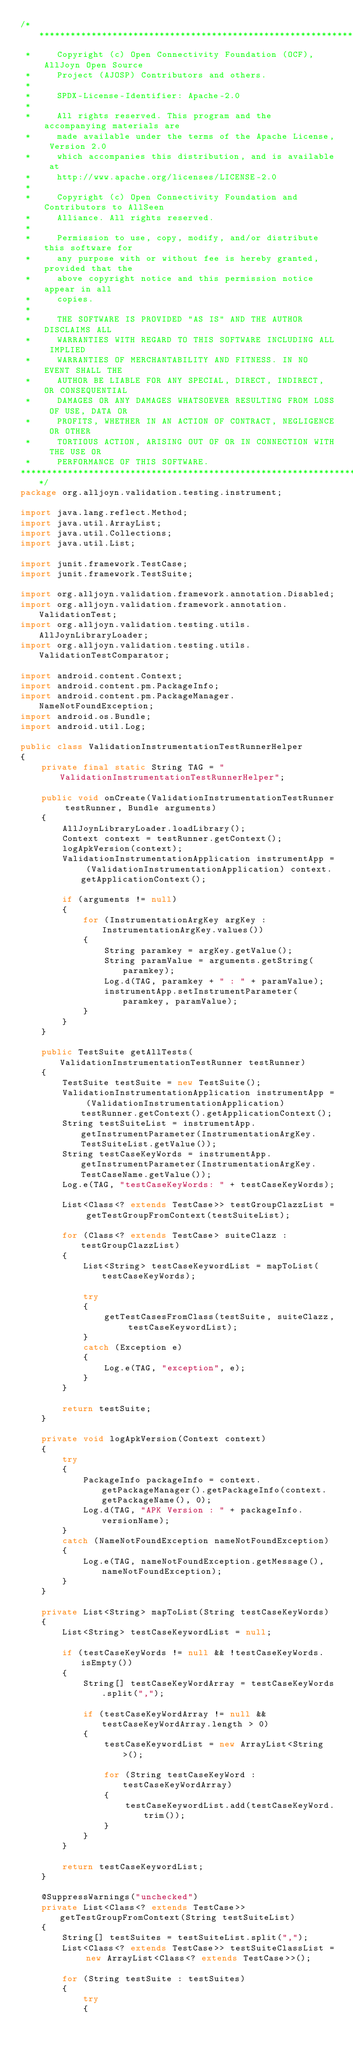Convert code to text. <code><loc_0><loc_0><loc_500><loc_500><_Java_>/*******************************************************************************
 *     Copyright (c) Open Connectivity Foundation (OCF), AllJoyn Open Source
 *     Project (AJOSP) Contributors and others.
 *     
 *     SPDX-License-Identifier: Apache-2.0
 *     
 *     All rights reserved. This program and the accompanying materials are
 *     made available under the terms of the Apache License, Version 2.0
 *     which accompanies this distribution, and is available at
 *     http://www.apache.org/licenses/LICENSE-2.0
 *     
 *     Copyright (c) Open Connectivity Foundation and Contributors to AllSeen
 *     Alliance. All rights reserved.
 *     
 *     Permission to use, copy, modify, and/or distribute this software for
 *     any purpose with or without fee is hereby granted, provided that the
 *     above copyright notice and this permission notice appear in all
 *     copies.
 *     
 *     THE SOFTWARE IS PROVIDED "AS IS" AND THE AUTHOR DISCLAIMS ALL
 *     WARRANTIES WITH REGARD TO THIS SOFTWARE INCLUDING ALL IMPLIED
 *     WARRANTIES OF MERCHANTABILITY AND FITNESS. IN NO EVENT SHALL THE
 *     AUTHOR BE LIABLE FOR ANY SPECIAL, DIRECT, INDIRECT, OR CONSEQUENTIAL
 *     DAMAGES OR ANY DAMAGES WHATSOEVER RESULTING FROM LOSS OF USE, DATA OR
 *     PROFITS, WHETHER IN AN ACTION OF CONTRACT, NEGLIGENCE OR OTHER
 *     TORTIOUS ACTION, ARISING OUT OF OR IN CONNECTION WITH THE USE OR
 *     PERFORMANCE OF THIS SOFTWARE.
*******************************************************************************/
package org.alljoyn.validation.testing.instrument;

import java.lang.reflect.Method;
import java.util.ArrayList;
import java.util.Collections;
import java.util.List;

import junit.framework.TestCase;
import junit.framework.TestSuite;

import org.alljoyn.validation.framework.annotation.Disabled;
import org.alljoyn.validation.framework.annotation.ValidationTest;
import org.alljoyn.validation.testing.utils.AllJoynLibraryLoader;
import org.alljoyn.validation.testing.utils.ValidationTestComparator;

import android.content.Context;
import android.content.pm.PackageInfo;
import android.content.pm.PackageManager.NameNotFoundException;
import android.os.Bundle;
import android.util.Log;

public class ValidationInstrumentationTestRunnerHelper
{
    private final static String TAG = "ValidationInstrumentationTestRunnerHelper";

    public void onCreate(ValidationInstrumentationTestRunner testRunner, Bundle arguments)
    {
        AllJoynLibraryLoader.loadLibrary();
        Context context = testRunner.getContext();
        logApkVersion(context);
        ValidationInstrumentationApplication instrumentApp = (ValidationInstrumentationApplication) context.getApplicationContext();

        if (arguments != null)
        {
            for (InstrumentationArgKey argKey : InstrumentationArgKey.values())
            {
                String paramkey = argKey.getValue();
                String paramValue = arguments.getString(paramkey);
                Log.d(TAG, paramkey + " : " + paramValue);
                instrumentApp.setInstrumentParameter(paramkey, paramValue);
            }
        }
    }

    public TestSuite getAllTests(ValidationInstrumentationTestRunner testRunner)
    {
        TestSuite testSuite = new TestSuite();
        ValidationInstrumentationApplication instrumentApp = (ValidationInstrumentationApplication) testRunner.getContext().getApplicationContext();
        String testSuiteList = instrumentApp.getInstrumentParameter(InstrumentationArgKey.TestSuiteList.getValue());
        String testCaseKeyWords = instrumentApp.getInstrumentParameter(InstrumentationArgKey.TestCaseName.getValue());
        Log.e(TAG, "testCaseKeyWords: " + testCaseKeyWords);

        List<Class<? extends TestCase>> testGroupClazzList = getTestGroupFromContext(testSuiteList);

        for (Class<? extends TestCase> suiteClazz : testGroupClazzList)
        {
            List<String> testCaseKeywordList = mapToList(testCaseKeyWords);

            try
            {
                getTestCasesFromClass(testSuite, suiteClazz, testCaseKeywordList);
            }
            catch (Exception e)
            {
                Log.e(TAG, "exception", e);
            }
        }

        return testSuite;
    }

    private void logApkVersion(Context context)
    {
        try
        {
            PackageInfo packageInfo = context.getPackageManager().getPackageInfo(context.getPackageName(), 0);
            Log.d(TAG, "APK Version : " + packageInfo.versionName);
        }
        catch (NameNotFoundException nameNotFoundException)
        {
            Log.e(TAG, nameNotFoundException.getMessage(), nameNotFoundException);
        }
    }

    private List<String> mapToList(String testCaseKeyWords)
    {
        List<String> testCaseKeywordList = null;

        if (testCaseKeyWords != null && !testCaseKeyWords.isEmpty())
        {
            String[] testCaseKeyWordArray = testCaseKeyWords.split(",");

            if (testCaseKeyWordArray != null && testCaseKeyWordArray.length > 0)
            {
                testCaseKeywordList = new ArrayList<String>();

                for (String testCaseKeyWord : testCaseKeyWordArray)
                {
                    testCaseKeywordList.add(testCaseKeyWord.trim());
                }
            }
        }

        return testCaseKeywordList;
    }

    @SuppressWarnings("unchecked")
    private List<Class<? extends TestCase>> getTestGroupFromContext(String testSuiteList)
    {
        String[] testSuites = testSuiteList.split(",");
        List<Class<? extends TestCase>> testSuiteClassList = new ArrayList<Class<? extends TestCase>>();

        for (String testSuite : testSuites)
        {
            try
            {</code> 